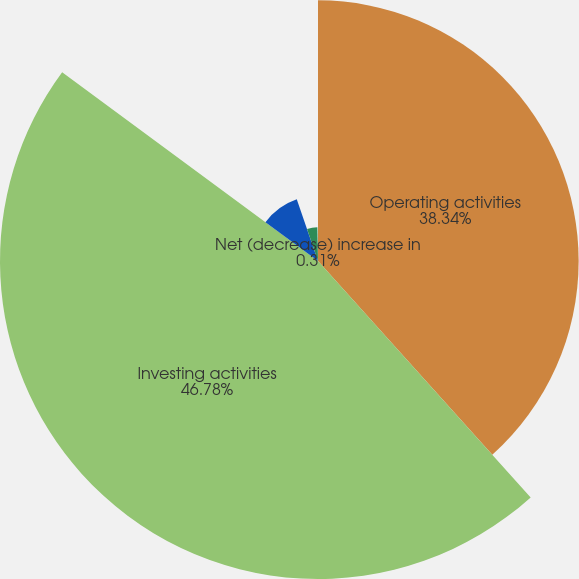<chart> <loc_0><loc_0><loc_500><loc_500><pie_chart><fcel>Operating activities<fcel>Investing activities<fcel>Financing activities<fcel>Effect of exchange rates on<fcel>Net (decrease) increase in<nl><fcel>38.34%<fcel>46.78%<fcel>9.61%<fcel>4.96%<fcel>0.31%<nl></chart> 